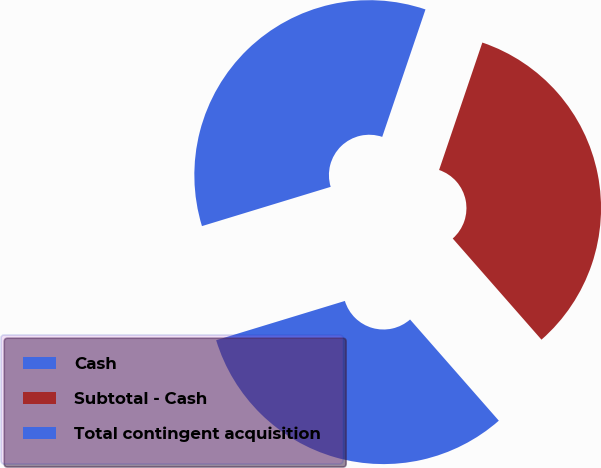<chart> <loc_0><loc_0><loc_500><loc_500><pie_chart><fcel>Cash<fcel>Subtotal - Cash<fcel>Total contingent acquisition<nl><fcel>31.75%<fcel>33.33%<fcel>34.92%<nl></chart> 